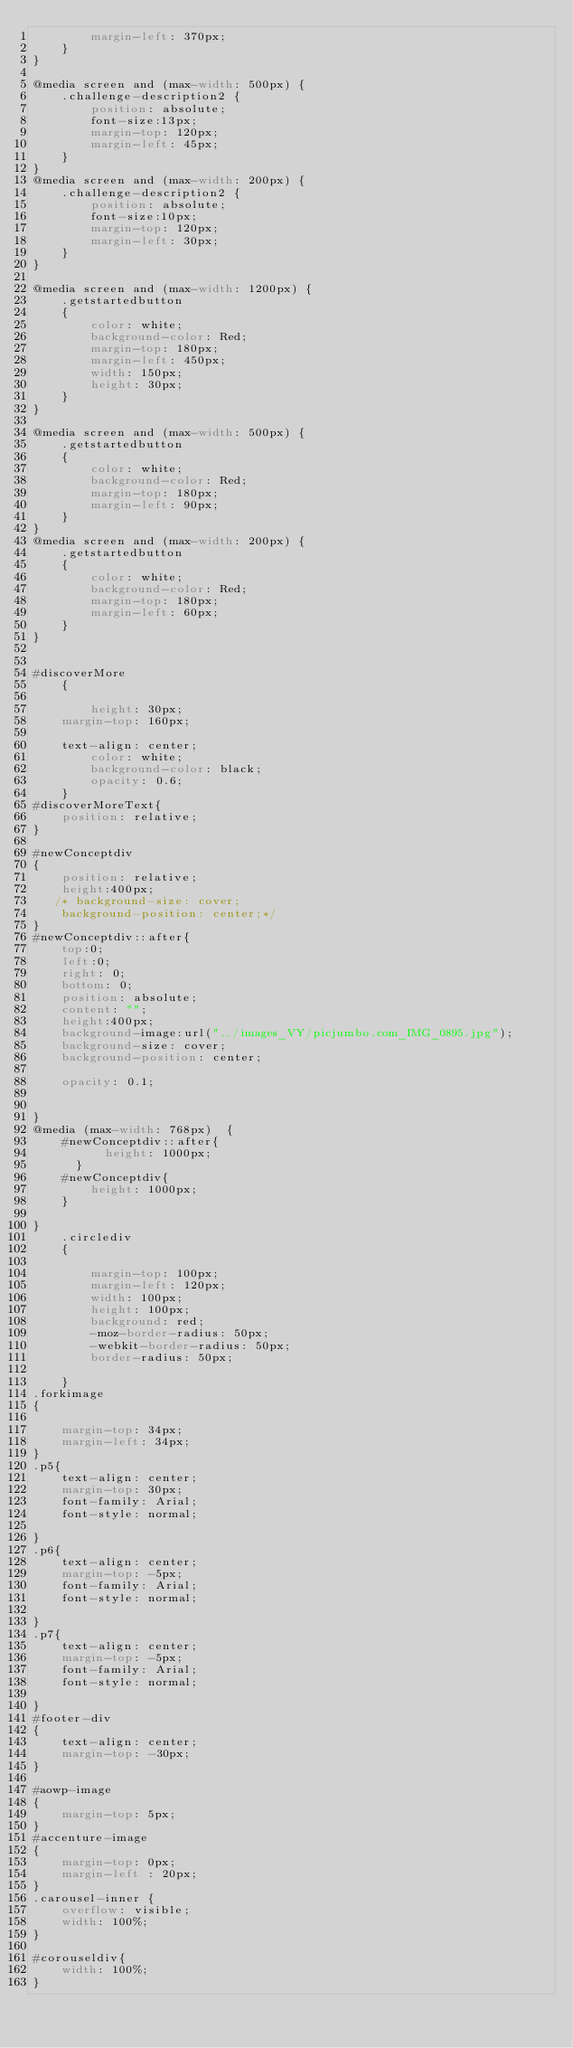<code> <loc_0><loc_0><loc_500><loc_500><_CSS_>        margin-left: 370px;
    }
}

@media screen and (max-width: 500px) {
    .challenge-description2 {
        position: absolute;
        font-size:13px;
        margin-top: 120px;
        margin-left: 45px;
    }
}
@media screen and (max-width: 200px) {
    .challenge-description2 {
        position: absolute;
        font-size:10px;
        margin-top: 120px;
        margin-left: 30px;
    }
}

@media screen and (max-width: 1200px) {
    .getstartedbutton
    {
        color: white;
        background-color: Red;
        margin-top: 180px;
        margin-left: 450px;
        width: 150px;
        height: 30px;
    }
}

@media screen and (max-width: 500px) {
    .getstartedbutton
    {
        color: white;
        background-color: Red;
        margin-top: 180px;
        margin-left: 90px;
    }
}
@media screen and (max-width: 200px) {
    .getstartedbutton
    {
        color: white;
        background-color: Red;
        margin-top: 180px;
        margin-left: 60px;
    }
}


#discoverMore
    {

        height: 30px;
    margin-top: 160px;

    text-align: center;
        color: white;
        background-color: black;
        opacity: 0.6;
    }
#discoverMoreText{
    position: relative;
}

#newConceptdiv
{
    position: relative;
    height:400px;
   /* background-size: cover;
    background-position: center;*/
}
#newConceptdiv::after{
    top:0;
    left:0;
    right: 0;
    bottom: 0;
    position: absolute;
    content: "";
    height:400px;
    background-image:url("../images_VY/picjumbo.com_IMG_0895.jpg");
    background-size: cover;
    background-position: center;

    opacity: 0.1;


}
@media (max-width: 768px)  {
    #newConceptdiv::after{
          height: 1000px;
      }
    #newConceptdiv{
        height: 1000px;
    }

}
    .circlediv
    {

        margin-top: 100px;
        margin-left: 120px;
        width: 100px;
        height: 100px;
        background: red;
        -moz-border-radius: 50px;
        -webkit-border-radius: 50px;
        border-radius: 50px;

    }
.forkimage
{

    margin-top: 34px;
    margin-left: 34px;
}
.p5{
    text-align: center;
    margin-top: 30px;
    font-family: Arial;
    font-style: normal;

}
.p6{
    text-align: center;
    margin-top: -5px;
    font-family: Arial;
    font-style: normal;

}
.p7{
    text-align: center;
    margin-top: -5px;
    font-family: Arial;
    font-style: normal;

}
#footer-div
{
    text-align: center;
    margin-top: -30px;
}

#aowp-image
{
    margin-top: 5px;
}
#accenture-image
{
    margin-top: 0px;
    margin-left : 20px;
}
.carousel-inner {
    overflow: visible;
    width: 100%;
}

#corouseldiv{
    width: 100%;
}





</code> 